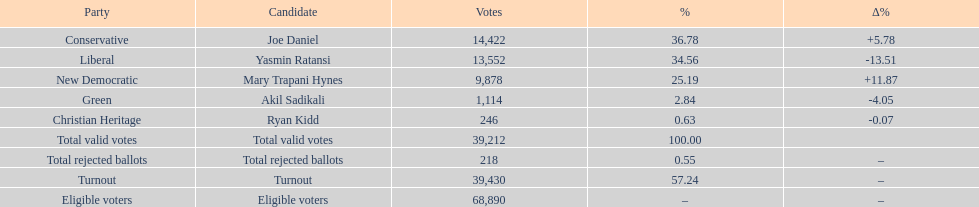Which candidate had the most votes? Joe Daniel. 